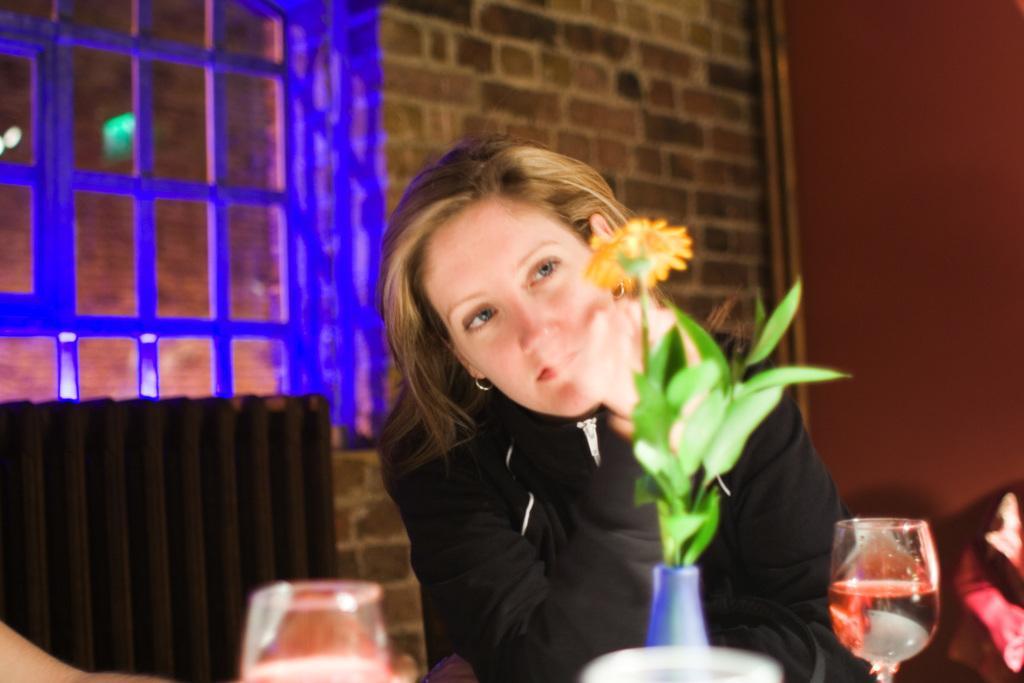How would you summarize this image in a sentence or two? In this picture we can see a person sitting on a chair. In front of her there is a flower vase and glasses on an object. Behind her there are windows and wall 